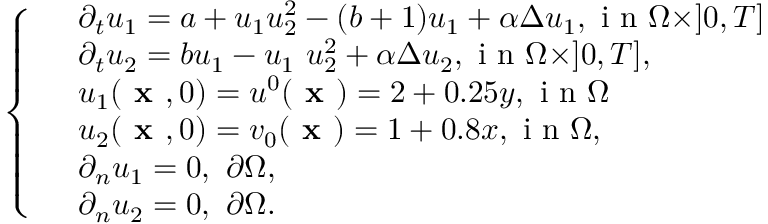Convert formula to latex. <formula><loc_0><loc_0><loc_500><loc_500>\left \{ \begin{array} { l l } & { \partial _ { t } u _ { 1 } = a + u _ { 1 } u _ { 2 } ^ { 2 } - ( b + 1 ) u _ { 1 } + \alpha \Delta u _ { 1 } , i n \Omega \times ] 0 , T ] } \\ & { \partial _ { t } u _ { 2 } = b u _ { 1 } - u _ { 1 } \ u _ { 2 } ^ { 2 } + \alpha \Delta u _ { 2 } , i n \Omega \times ] 0 , T ] , } \\ & { u _ { 1 } ( x , 0 ) = u ^ { 0 } ( x ) = 2 + 0 . 2 5 y , i n \Omega } \\ & { u _ { 2 } ( x , 0 ) = v _ { 0 } ( x ) = 1 + 0 . 8 x , i n \Omega , } \\ & { \partial _ { n } u _ { 1 } = 0 , \ \partial \Omega , } \\ & { \partial _ { n } u _ { 2 } = 0 , \ \partial \Omega . } \end{array}</formula> 